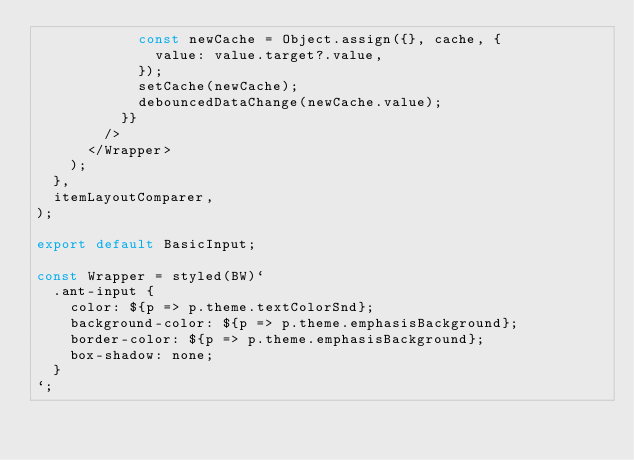<code> <loc_0><loc_0><loc_500><loc_500><_TypeScript_>            const newCache = Object.assign({}, cache, {
              value: value.target?.value,
            });
            setCache(newCache);
            debouncedDataChange(newCache.value);
          }}
        />
      </Wrapper>
    );
  },
  itemLayoutComparer,
);

export default BasicInput;

const Wrapper = styled(BW)`
  .ant-input {
    color: ${p => p.theme.textColorSnd};
    background-color: ${p => p.theme.emphasisBackground};
    border-color: ${p => p.theme.emphasisBackground};
    box-shadow: none;
  }
`;
</code> 